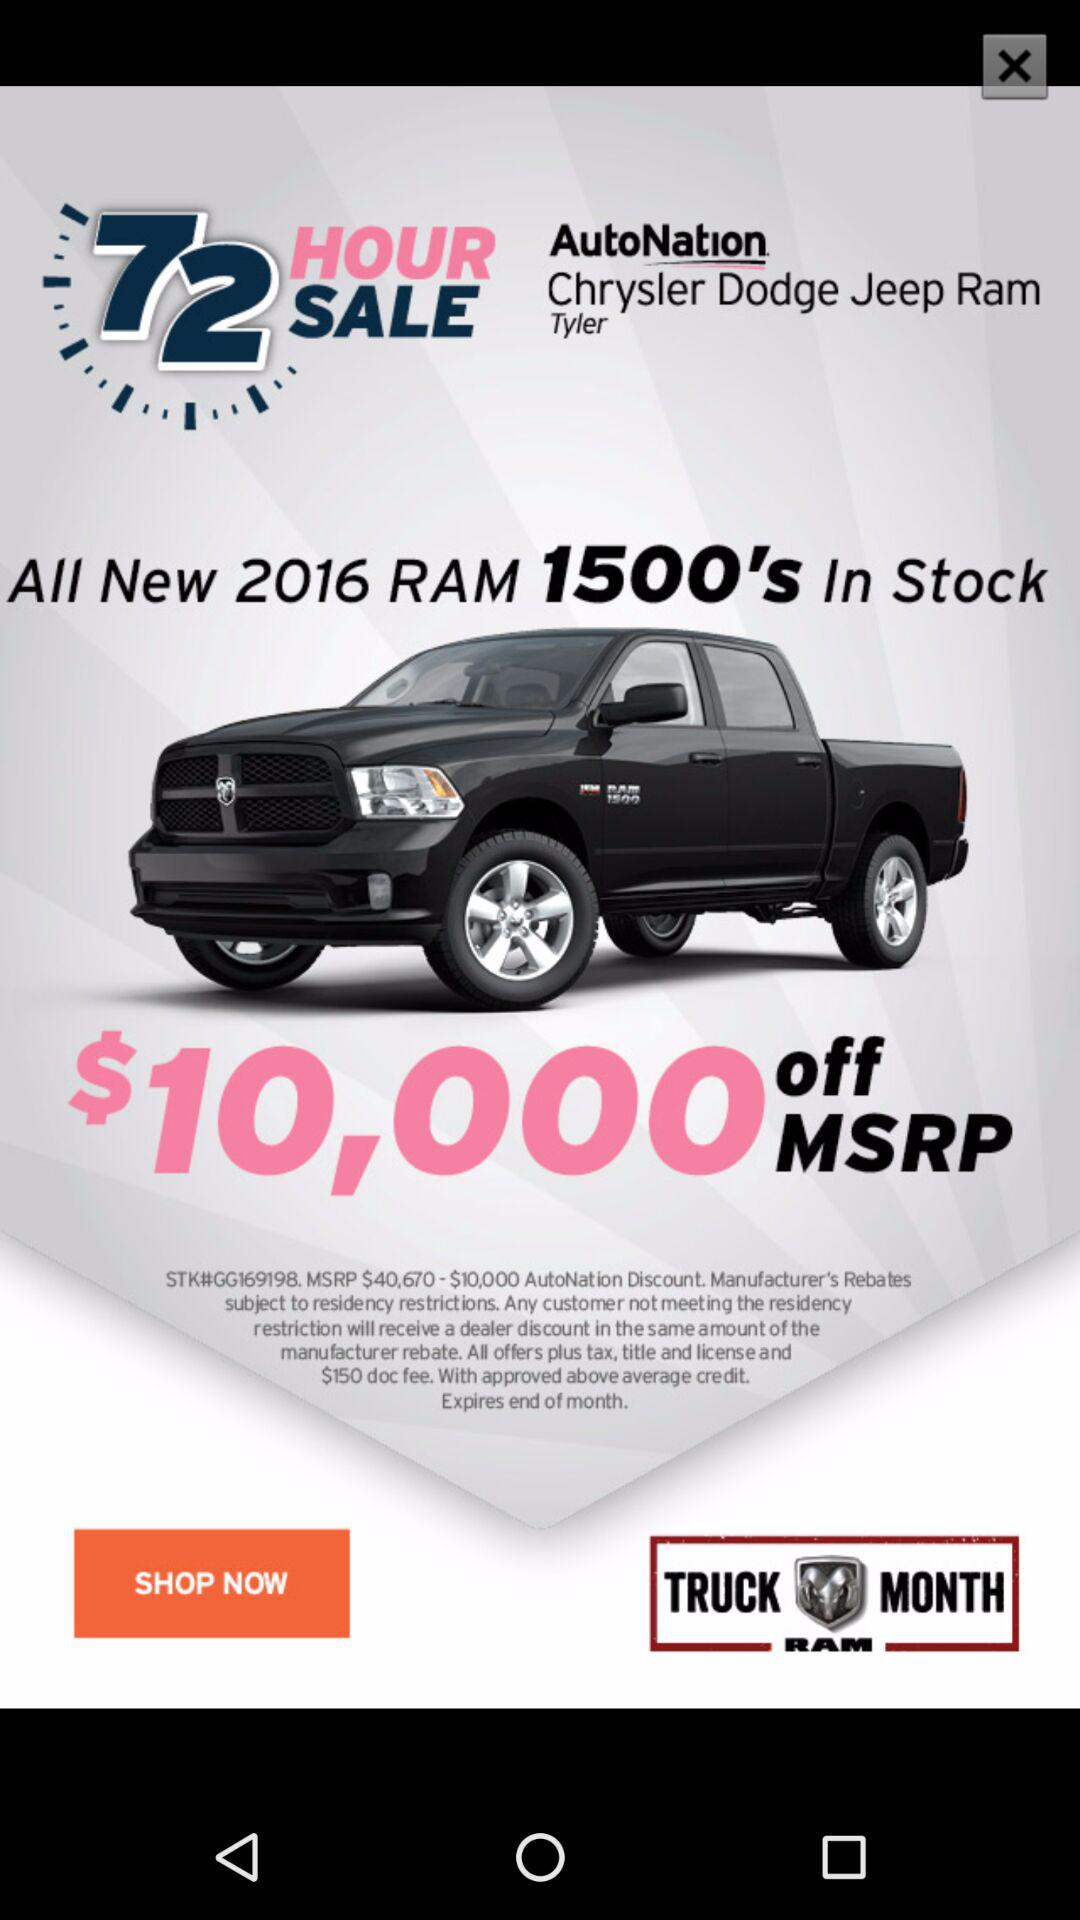How much is the MSRP of the Ram 1500?
Answer the question using a single word or phrase. $40,670 